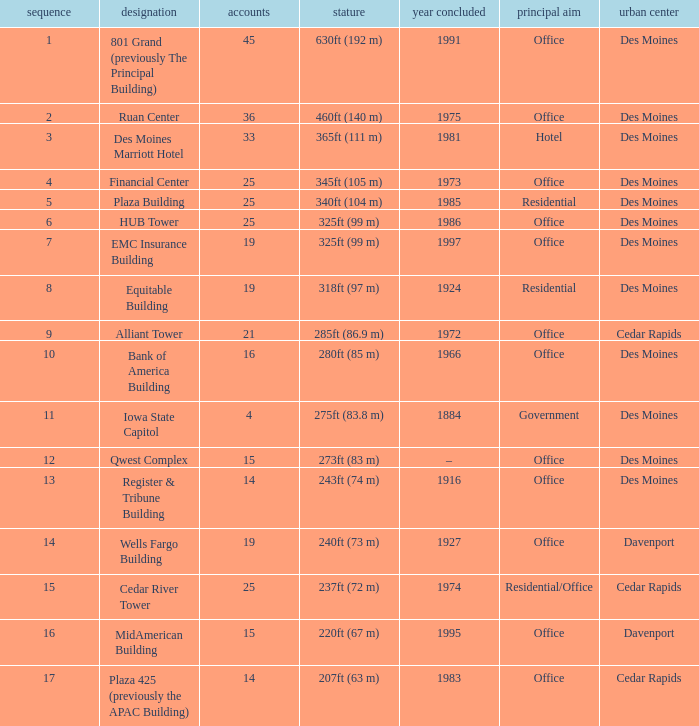What is the height of the EMC Insurance Building in Des Moines? 325ft (99 m). 